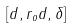<formula> <loc_0><loc_0><loc_500><loc_500>[ d , r _ { o } d , \delta ]</formula> 